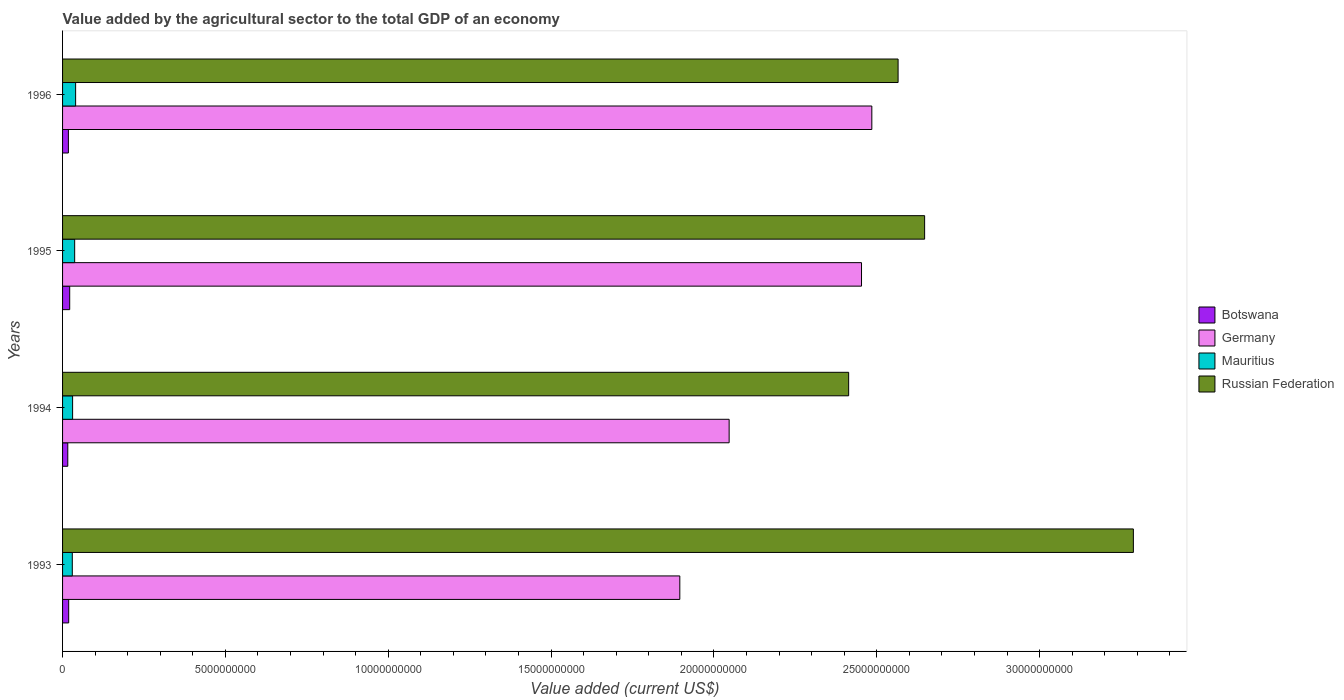How many different coloured bars are there?
Provide a succinct answer. 4. Are the number of bars on each tick of the Y-axis equal?
Offer a terse response. Yes. How many bars are there on the 2nd tick from the top?
Give a very brief answer. 4. What is the label of the 2nd group of bars from the top?
Offer a very short reply. 1995. What is the value added by the agricultural sector to the total GDP in Germany in 1994?
Make the answer very short. 2.05e+1. Across all years, what is the maximum value added by the agricultural sector to the total GDP in Germany?
Ensure brevity in your answer.  2.48e+1. Across all years, what is the minimum value added by the agricultural sector to the total GDP in Mauritius?
Your answer should be compact. 2.99e+08. In which year was the value added by the agricultural sector to the total GDP in Russian Federation minimum?
Give a very brief answer. 1994. What is the total value added by the agricultural sector to the total GDP in Germany in the graph?
Your response must be concise. 8.88e+1. What is the difference between the value added by the agricultural sector to the total GDP in Botswana in 1993 and that in 1995?
Your response must be concise. -3.13e+07. What is the difference between the value added by the agricultural sector to the total GDP in Russian Federation in 1994 and the value added by the agricultural sector to the total GDP in Germany in 1996?
Give a very brief answer. -7.12e+08. What is the average value added by the agricultural sector to the total GDP in Russian Federation per year?
Offer a terse response. 2.73e+1. In the year 1993, what is the difference between the value added by the agricultural sector to the total GDP in Mauritius and value added by the agricultural sector to the total GDP in Germany?
Provide a succinct answer. -1.87e+1. What is the ratio of the value added by the agricultural sector to the total GDP in Russian Federation in 1993 to that in 1995?
Your answer should be very brief. 1.24. Is the value added by the agricultural sector to the total GDP in Germany in 1995 less than that in 1996?
Your answer should be compact. Yes. Is the difference between the value added by the agricultural sector to the total GDP in Mauritius in 1993 and 1996 greater than the difference between the value added by the agricultural sector to the total GDP in Germany in 1993 and 1996?
Offer a terse response. Yes. What is the difference between the highest and the second highest value added by the agricultural sector to the total GDP in Mauritius?
Offer a very short reply. 2.91e+07. What is the difference between the highest and the lowest value added by the agricultural sector to the total GDP in Mauritius?
Make the answer very short. 1.02e+08. In how many years, is the value added by the agricultural sector to the total GDP in Botswana greater than the average value added by the agricultural sector to the total GDP in Botswana taken over all years?
Give a very brief answer. 2. Is it the case that in every year, the sum of the value added by the agricultural sector to the total GDP in Russian Federation and value added by the agricultural sector to the total GDP in Germany is greater than the sum of value added by the agricultural sector to the total GDP in Botswana and value added by the agricultural sector to the total GDP in Mauritius?
Your response must be concise. Yes. What does the 4th bar from the top in 1996 represents?
Your answer should be compact. Botswana. What does the 2nd bar from the bottom in 1995 represents?
Provide a short and direct response. Germany. Is it the case that in every year, the sum of the value added by the agricultural sector to the total GDP in Russian Federation and value added by the agricultural sector to the total GDP in Germany is greater than the value added by the agricultural sector to the total GDP in Botswana?
Keep it short and to the point. Yes. Are all the bars in the graph horizontal?
Your response must be concise. Yes. Does the graph contain any zero values?
Your answer should be compact. No. Does the graph contain grids?
Your answer should be compact. No. Where does the legend appear in the graph?
Ensure brevity in your answer.  Center right. What is the title of the graph?
Your response must be concise. Value added by the agricultural sector to the total GDP of an economy. What is the label or title of the X-axis?
Your response must be concise. Value added (current US$). What is the Value added (current US$) of Botswana in 1993?
Offer a very short reply. 1.88e+08. What is the Value added (current US$) in Germany in 1993?
Your answer should be very brief. 1.90e+1. What is the Value added (current US$) of Mauritius in 1993?
Provide a succinct answer. 2.99e+08. What is the Value added (current US$) of Russian Federation in 1993?
Ensure brevity in your answer.  3.29e+1. What is the Value added (current US$) of Botswana in 1994?
Provide a succinct answer. 1.60e+08. What is the Value added (current US$) in Germany in 1994?
Provide a short and direct response. 2.05e+1. What is the Value added (current US$) in Mauritius in 1994?
Ensure brevity in your answer.  3.08e+08. What is the Value added (current US$) in Russian Federation in 1994?
Ensure brevity in your answer.  2.41e+1. What is the Value added (current US$) of Botswana in 1995?
Your answer should be very brief. 2.19e+08. What is the Value added (current US$) in Germany in 1995?
Ensure brevity in your answer.  2.45e+1. What is the Value added (current US$) in Mauritius in 1995?
Ensure brevity in your answer.  3.72e+08. What is the Value added (current US$) in Russian Federation in 1995?
Offer a very short reply. 2.65e+1. What is the Value added (current US$) of Botswana in 1996?
Your answer should be very brief. 1.79e+08. What is the Value added (current US$) of Germany in 1996?
Your answer should be very brief. 2.48e+1. What is the Value added (current US$) in Mauritius in 1996?
Offer a very short reply. 4.01e+08. What is the Value added (current US$) of Russian Federation in 1996?
Offer a very short reply. 2.57e+1. Across all years, what is the maximum Value added (current US$) in Botswana?
Provide a short and direct response. 2.19e+08. Across all years, what is the maximum Value added (current US$) of Germany?
Offer a very short reply. 2.48e+1. Across all years, what is the maximum Value added (current US$) in Mauritius?
Offer a very short reply. 4.01e+08. Across all years, what is the maximum Value added (current US$) of Russian Federation?
Keep it short and to the point. 3.29e+1. Across all years, what is the minimum Value added (current US$) in Botswana?
Your answer should be very brief. 1.60e+08. Across all years, what is the minimum Value added (current US$) in Germany?
Offer a terse response. 1.90e+1. Across all years, what is the minimum Value added (current US$) in Mauritius?
Your answer should be very brief. 2.99e+08. Across all years, what is the minimum Value added (current US$) of Russian Federation?
Make the answer very short. 2.41e+1. What is the total Value added (current US$) in Botswana in the graph?
Make the answer very short. 7.46e+08. What is the total Value added (current US$) of Germany in the graph?
Provide a short and direct response. 8.88e+1. What is the total Value added (current US$) of Mauritius in the graph?
Make the answer very short. 1.38e+09. What is the total Value added (current US$) of Russian Federation in the graph?
Provide a succinct answer. 1.09e+11. What is the difference between the Value added (current US$) in Botswana in 1993 and that in 1994?
Your answer should be very brief. 2.81e+07. What is the difference between the Value added (current US$) of Germany in 1993 and that in 1994?
Your answer should be compact. -1.51e+09. What is the difference between the Value added (current US$) of Mauritius in 1993 and that in 1994?
Offer a terse response. -9.72e+06. What is the difference between the Value added (current US$) of Russian Federation in 1993 and that in 1994?
Ensure brevity in your answer.  8.74e+09. What is the difference between the Value added (current US$) in Botswana in 1993 and that in 1995?
Offer a terse response. -3.13e+07. What is the difference between the Value added (current US$) of Germany in 1993 and that in 1995?
Keep it short and to the point. -5.58e+09. What is the difference between the Value added (current US$) in Mauritius in 1993 and that in 1995?
Provide a succinct answer. -7.30e+07. What is the difference between the Value added (current US$) of Russian Federation in 1993 and that in 1995?
Offer a very short reply. 6.41e+09. What is the difference between the Value added (current US$) of Botswana in 1993 and that in 1996?
Your answer should be compact. 9.16e+06. What is the difference between the Value added (current US$) of Germany in 1993 and that in 1996?
Offer a terse response. -5.90e+09. What is the difference between the Value added (current US$) in Mauritius in 1993 and that in 1996?
Keep it short and to the point. -1.02e+08. What is the difference between the Value added (current US$) of Russian Federation in 1993 and that in 1996?
Your response must be concise. 7.22e+09. What is the difference between the Value added (current US$) of Botswana in 1994 and that in 1995?
Offer a very short reply. -5.94e+07. What is the difference between the Value added (current US$) of Germany in 1994 and that in 1995?
Make the answer very short. -4.06e+09. What is the difference between the Value added (current US$) of Mauritius in 1994 and that in 1995?
Give a very brief answer. -6.33e+07. What is the difference between the Value added (current US$) in Russian Federation in 1994 and that in 1995?
Offer a terse response. -2.33e+09. What is the difference between the Value added (current US$) in Botswana in 1994 and that in 1996?
Your response must be concise. -1.89e+07. What is the difference between the Value added (current US$) of Germany in 1994 and that in 1996?
Provide a short and direct response. -4.38e+09. What is the difference between the Value added (current US$) of Mauritius in 1994 and that in 1996?
Make the answer very short. -9.24e+07. What is the difference between the Value added (current US$) in Russian Federation in 1994 and that in 1996?
Offer a terse response. -1.52e+09. What is the difference between the Value added (current US$) in Botswana in 1995 and that in 1996?
Provide a short and direct response. 4.05e+07. What is the difference between the Value added (current US$) of Germany in 1995 and that in 1996?
Your answer should be very brief. -3.17e+08. What is the difference between the Value added (current US$) of Mauritius in 1995 and that in 1996?
Offer a very short reply. -2.91e+07. What is the difference between the Value added (current US$) of Russian Federation in 1995 and that in 1996?
Make the answer very short. 8.15e+08. What is the difference between the Value added (current US$) of Botswana in 1993 and the Value added (current US$) of Germany in 1994?
Offer a very short reply. -2.03e+1. What is the difference between the Value added (current US$) of Botswana in 1993 and the Value added (current US$) of Mauritius in 1994?
Provide a succinct answer. -1.20e+08. What is the difference between the Value added (current US$) of Botswana in 1993 and the Value added (current US$) of Russian Federation in 1994?
Give a very brief answer. -2.39e+1. What is the difference between the Value added (current US$) of Germany in 1993 and the Value added (current US$) of Mauritius in 1994?
Provide a short and direct response. 1.86e+1. What is the difference between the Value added (current US$) in Germany in 1993 and the Value added (current US$) in Russian Federation in 1994?
Give a very brief answer. -5.18e+09. What is the difference between the Value added (current US$) of Mauritius in 1993 and the Value added (current US$) of Russian Federation in 1994?
Keep it short and to the point. -2.38e+1. What is the difference between the Value added (current US$) in Botswana in 1993 and the Value added (current US$) in Germany in 1995?
Offer a terse response. -2.43e+1. What is the difference between the Value added (current US$) of Botswana in 1993 and the Value added (current US$) of Mauritius in 1995?
Provide a succinct answer. -1.84e+08. What is the difference between the Value added (current US$) of Botswana in 1993 and the Value added (current US$) of Russian Federation in 1995?
Offer a very short reply. -2.63e+1. What is the difference between the Value added (current US$) in Germany in 1993 and the Value added (current US$) in Mauritius in 1995?
Your answer should be very brief. 1.86e+1. What is the difference between the Value added (current US$) of Germany in 1993 and the Value added (current US$) of Russian Federation in 1995?
Your response must be concise. -7.52e+09. What is the difference between the Value added (current US$) in Mauritius in 1993 and the Value added (current US$) in Russian Federation in 1995?
Offer a terse response. -2.62e+1. What is the difference between the Value added (current US$) in Botswana in 1993 and the Value added (current US$) in Germany in 1996?
Offer a very short reply. -2.47e+1. What is the difference between the Value added (current US$) in Botswana in 1993 and the Value added (current US$) in Mauritius in 1996?
Ensure brevity in your answer.  -2.13e+08. What is the difference between the Value added (current US$) of Botswana in 1993 and the Value added (current US$) of Russian Federation in 1996?
Your response must be concise. -2.55e+1. What is the difference between the Value added (current US$) of Germany in 1993 and the Value added (current US$) of Mauritius in 1996?
Provide a short and direct response. 1.86e+1. What is the difference between the Value added (current US$) of Germany in 1993 and the Value added (current US$) of Russian Federation in 1996?
Provide a short and direct response. -6.70e+09. What is the difference between the Value added (current US$) of Mauritius in 1993 and the Value added (current US$) of Russian Federation in 1996?
Offer a very short reply. -2.54e+1. What is the difference between the Value added (current US$) in Botswana in 1994 and the Value added (current US$) in Germany in 1995?
Make the answer very short. -2.44e+1. What is the difference between the Value added (current US$) in Botswana in 1994 and the Value added (current US$) in Mauritius in 1995?
Your response must be concise. -2.12e+08. What is the difference between the Value added (current US$) of Botswana in 1994 and the Value added (current US$) of Russian Federation in 1995?
Offer a terse response. -2.63e+1. What is the difference between the Value added (current US$) in Germany in 1994 and the Value added (current US$) in Mauritius in 1995?
Provide a short and direct response. 2.01e+1. What is the difference between the Value added (current US$) in Germany in 1994 and the Value added (current US$) in Russian Federation in 1995?
Your response must be concise. -6.00e+09. What is the difference between the Value added (current US$) in Mauritius in 1994 and the Value added (current US$) in Russian Federation in 1995?
Provide a short and direct response. -2.62e+1. What is the difference between the Value added (current US$) in Botswana in 1994 and the Value added (current US$) in Germany in 1996?
Your answer should be very brief. -2.47e+1. What is the difference between the Value added (current US$) in Botswana in 1994 and the Value added (current US$) in Mauritius in 1996?
Ensure brevity in your answer.  -2.41e+08. What is the difference between the Value added (current US$) in Botswana in 1994 and the Value added (current US$) in Russian Federation in 1996?
Ensure brevity in your answer.  -2.55e+1. What is the difference between the Value added (current US$) of Germany in 1994 and the Value added (current US$) of Mauritius in 1996?
Provide a short and direct response. 2.01e+1. What is the difference between the Value added (current US$) of Germany in 1994 and the Value added (current US$) of Russian Federation in 1996?
Provide a succinct answer. -5.19e+09. What is the difference between the Value added (current US$) in Mauritius in 1994 and the Value added (current US$) in Russian Federation in 1996?
Make the answer very short. -2.53e+1. What is the difference between the Value added (current US$) of Botswana in 1995 and the Value added (current US$) of Germany in 1996?
Give a very brief answer. -2.46e+1. What is the difference between the Value added (current US$) in Botswana in 1995 and the Value added (current US$) in Mauritius in 1996?
Provide a succinct answer. -1.81e+08. What is the difference between the Value added (current US$) in Botswana in 1995 and the Value added (current US$) in Russian Federation in 1996?
Ensure brevity in your answer.  -2.54e+1. What is the difference between the Value added (current US$) of Germany in 1995 and the Value added (current US$) of Mauritius in 1996?
Make the answer very short. 2.41e+1. What is the difference between the Value added (current US$) of Germany in 1995 and the Value added (current US$) of Russian Federation in 1996?
Give a very brief answer. -1.12e+09. What is the difference between the Value added (current US$) of Mauritius in 1995 and the Value added (current US$) of Russian Federation in 1996?
Offer a very short reply. -2.53e+1. What is the average Value added (current US$) of Botswana per year?
Your response must be concise. 1.87e+08. What is the average Value added (current US$) in Germany per year?
Make the answer very short. 2.22e+1. What is the average Value added (current US$) in Mauritius per year?
Ensure brevity in your answer.  3.45e+08. What is the average Value added (current US$) in Russian Federation per year?
Your response must be concise. 2.73e+1. In the year 1993, what is the difference between the Value added (current US$) of Botswana and Value added (current US$) of Germany?
Make the answer very short. -1.88e+1. In the year 1993, what is the difference between the Value added (current US$) of Botswana and Value added (current US$) of Mauritius?
Your response must be concise. -1.11e+08. In the year 1993, what is the difference between the Value added (current US$) in Botswana and Value added (current US$) in Russian Federation?
Your answer should be very brief. -3.27e+1. In the year 1993, what is the difference between the Value added (current US$) of Germany and Value added (current US$) of Mauritius?
Provide a succinct answer. 1.87e+1. In the year 1993, what is the difference between the Value added (current US$) in Germany and Value added (current US$) in Russian Federation?
Provide a short and direct response. -1.39e+1. In the year 1993, what is the difference between the Value added (current US$) in Mauritius and Value added (current US$) in Russian Federation?
Ensure brevity in your answer.  -3.26e+1. In the year 1994, what is the difference between the Value added (current US$) of Botswana and Value added (current US$) of Germany?
Provide a succinct answer. -2.03e+1. In the year 1994, what is the difference between the Value added (current US$) in Botswana and Value added (current US$) in Mauritius?
Ensure brevity in your answer.  -1.48e+08. In the year 1994, what is the difference between the Value added (current US$) of Botswana and Value added (current US$) of Russian Federation?
Offer a very short reply. -2.40e+1. In the year 1994, what is the difference between the Value added (current US$) in Germany and Value added (current US$) in Mauritius?
Offer a very short reply. 2.02e+1. In the year 1994, what is the difference between the Value added (current US$) in Germany and Value added (current US$) in Russian Federation?
Ensure brevity in your answer.  -3.67e+09. In the year 1994, what is the difference between the Value added (current US$) of Mauritius and Value added (current US$) of Russian Federation?
Provide a succinct answer. -2.38e+1. In the year 1995, what is the difference between the Value added (current US$) in Botswana and Value added (current US$) in Germany?
Keep it short and to the point. -2.43e+1. In the year 1995, what is the difference between the Value added (current US$) of Botswana and Value added (current US$) of Mauritius?
Keep it short and to the point. -1.52e+08. In the year 1995, what is the difference between the Value added (current US$) in Botswana and Value added (current US$) in Russian Federation?
Offer a very short reply. -2.63e+1. In the year 1995, what is the difference between the Value added (current US$) in Germany and Value added (current US$) in Mauritius?
Make the answer very short. 2.42e+1. In the year 1995, what is the difference between the Value added (current US$) of Germany and Value added (current US$) of Russian Federation?
Give a very brief answer. -1.94e+09. In the year 1995, what is the difference between the Value added (current US$) of Mauritius and Value added (current US$) of Russian Federation?
Offer a very short reply. -2.61e+1. In the year 1996, what is the difference between the Value added (current US$) of Botswana and Value added (current US$) of Germany?
Provide a short and direct response. -2.47e+1. In the year 1996, what is the difference between the Value added (current US$) of Botswana and Value added (current US$) of Mauritius?
Offer a very short reply. -2.22e+08. In the year 1996, what is the difference between the Value added (current US$) of Botswana and Value added (current US$) of Russian Federation?
Offer a terse response. -2.55e+1. In the year 1996, what is the difference between the Value added (current US$) of Germany and Value added (current US$) of Mauritius?
Keep it short and to the point. 2.44e+1. In the year 1996, what is the difference between the Value added (current US$) in Germany and Value added (current US$) in Russian Federation?
Keep it short and to the point. -8.06e+08. In the year 1996, what is the difference between the Value added (current US$) in Mauritius and Value added (current US$) in Russian Federation?
Offer a terse response. -2.53e+1. What is the ratio of the Value added (current US$) in Botswana in 1993 to that in 1994?
Keep it short and to the point. 1.18. What is the ratio of the Value added (current US$) of Germany in 1993 to that in 1994?
Provide a short and direct response. 0.93. What is the ratio of the Value added (current US$) in Mauritius in 1993 to that in 1994?
Make the answer very short. 0.97. What is the ratio of the Value added (current US$) of Russian Federation in 1993 to that in 1994?
Ensure brevity in your answer.  1.36. What is the ratio of the Value added (current US$) in Botswana in 1993 to that in 1995?
Keep it short and to the point. 0.86. What is the ratio of the Value added (current US$) in Germany in 1993 to that in 1995?
Provide a succinct answer. 0.77. What is the ratio of the Value added (current US$) in Mauritius in 1993 to that in 1995?
Offer a very short reply. 0.8. What is the ratio of the Value added (current US$) in Russian Federation in 1993 to that in 1995?
Offer a terse response. 1.24. What is the ratio of the Value added (current US$) in Botswana in 1993 to that in 1996?
Provide a short and direct response. 1.05. What is the ratio of the Value added (current US$) of Germany in 1993 to that in 1996?
Give a very brief answer. 0.76. What is the ratio of the Value added (current US$) in Mauritius in 1993 to that in 1996?
Ensure brevity in your answer.  0.75. What is the ratio of the Value added (current US$) in Russian Federation in 1993 to that in 1996?
Offer a terse response. 1.28. What is the ratio of the Value added (current US$) in Botswana in 1994 to that in 1995?
Offer a very short reply. 0.73. What is the ratio of the Value added (current US$) in Germany in 1994 to that in 1995?
Keep it short and to the point. 0.83. What is the ratio of the Value added (current US$) in Mauritius in 1994 to that in 1995?
Provide a succinct answer. 0.83. What is the ratio of the Value added (current US$) of Russian Federation in 1994 to that in 1995?
Offer a terse response. 0.91. What is the ratio of the Value added (current US$) of Botswana in 1994 to that in 1996?
Provide a succinct answer. 0.89. What is the ratio of the Value added (current US$) in Germany in 1994 to that in 1996?
Make the answer very short. 0.82. What is the ratio of the Value added (current US$) of Mauritius in 1994 to that in 1996?
Make the answer very short. 0.77. What is the ratio of the Value added (current US$) in Russian Federation in 1994 to that in 1996?
Offer a terse response. 0.94. What is the ratio of the Value added (current US$) in Botswana in 1995 to that in 1996?
Make the answer very short. 1.23. What is the ratio of the Value added (current US$) in Germany in 1995 to that in 1996?
Make the answer very short. 0.99. What is the ratio of the Value added (current US$) of Mauritius in 1995 to that in 1996?
Provide a short and direct response. 0.93. What is the ratio of the Value added (current US$) of Russian Federation in 1995 to that in 1996?
Provide a short and direct response. 1.03. What is the difference between the highest and the second highest Value added (current US$) in Botswana?
Give a very brief answer. 3.13e+07. What is the difference between the highest and the second highest Value added (current US$) in Germany?
Offer a terse response. 3.17e+08. What is the difference between the highest and the second highest Value added (current US$) in Mauritius?
Make the answer very short. 2.91e+07. What is the difference between the highest and the second highest Value added (current US$) in Russian Federation?
Your answer should be very brief. 6.41e+09. What is the difference between the highest and the lowest Value added (current US$) in Botswana?
Keep it short and to the point. 5.94e+07. What is the difference between the highest and the lowest Value added (current US$) of Germany?
Keep it short and to the point. 5.90e+09. What is the difference between the highest and the lowest Value added (current US$) of Mauritius?
Your response must be concise. 1.02e+08. What is the difference between the highest and the lowest Value added (current US$) in Russian Federation?
Keep it short and to the point. 8.74e+09. 